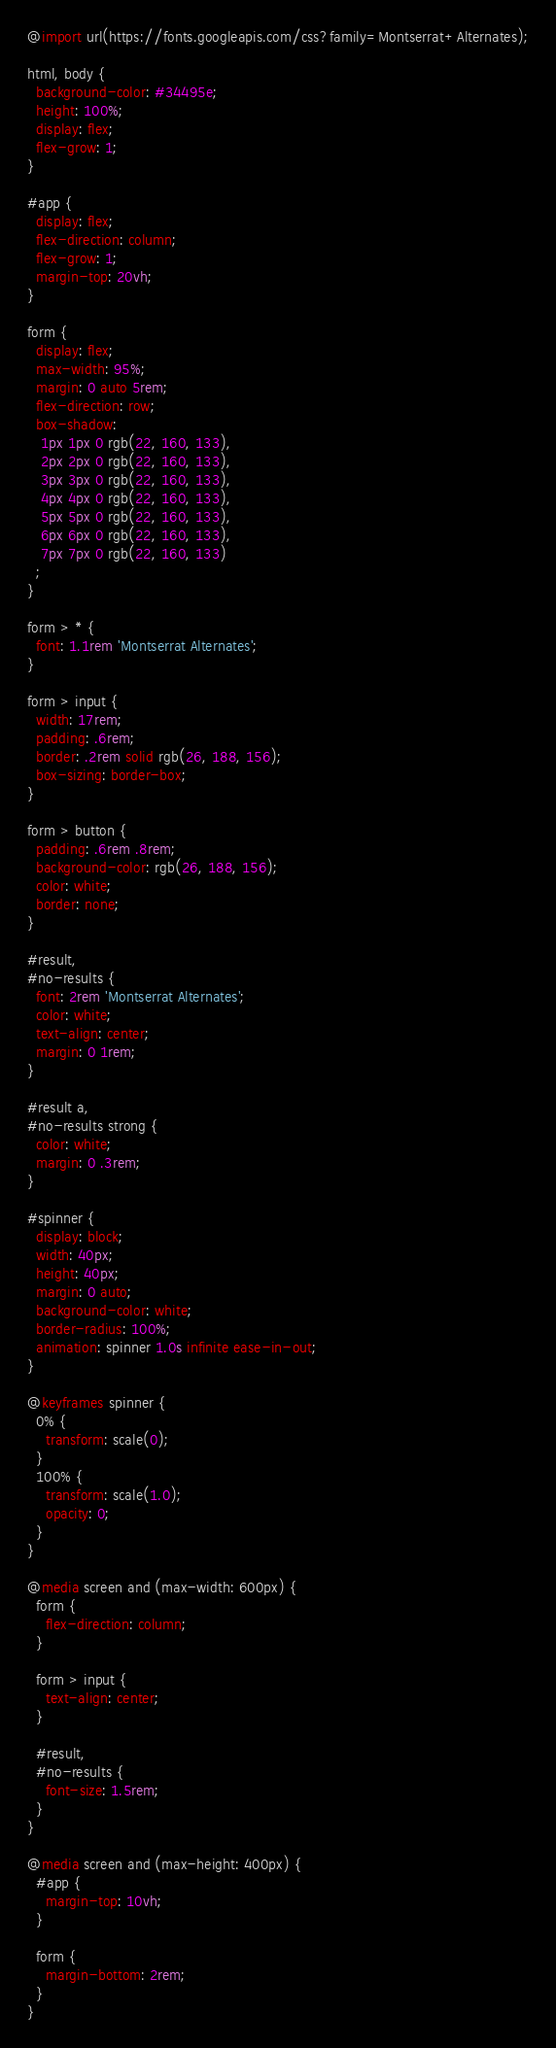<code> <loc_0><loc_0><loc_500><loc_500><_CSS_>@import url(https://fonts.googleapis.com/css?family=Montserrat+Alternates);

html, body {
  background-color: #34495e;
  height: 100%;
  display: flex;
  flex-grow: 1;
}

#app {
  display: flex;
  flex-direction: column;
  flex-grow: 1;
  margin-top: 20vh;
}

form {
  display: flex;
  max-width: 95%;
  margin: 0 auto 5rem;
  flex-direction: row;
  box-shadow:
   1px 1px 0 rgb(22, 160, 133),
   2px 2px 0 rgb(22, 160, 133),
   3px 3px 0 rgb(22, 160, 133),
   4px 4px 0 rgb(22, 160, 133),
   5px 5px 0 rgb(22, 160, 133),
   6px 6px 0 rgb(22, 160, 133),
   7px 7px 0 rgb(22, 160, 133)
  ;
}

form > * {
  font: 1.1rem 'Montserrat Alternates';
}

form > input {
  width: 17rem;
  padding: .6rem;
  border: .2rem solid rgb(26, 188, 156);
  box-sizing: border-box;
}

form > button {
  padding: .6rem .8rem;
  background-color: rgb(26, 188, 156);
  color: white;
  border: none;
}

#result,
#no-results {
  font: 2rem 'Montserrat Alternates';
  color: white;
  text-align: center;
  margin: 0 1rem;
}

#result a,
#no-results strong {
  color: white;
  margin: 0 .3rem;
}

#spinner {
  display: block;
  width: 40px;
  height: 40px;
  margin: 0 auto;
  background-color: white;
  border-radius: 100%;
  animation: spinner 1.0s infinite ease-in-out;
}

@keyframes spinner {
  0% {
    transform: scale(0);
  }
  100% {
    transform: scale(1.0);
    opacity: 0;
  }
}

@media screen and (max-width: 600px) {
  form {
    flex-direction: column;
  }

  form > input {
    text-align: center;
  }

  #result,
  #no-results {
    font-size: 1.5rem;
  }
}

@media screen and (max-height: 400px) {
  #app {
    margin-top: 10vh;
  }

  form {
    margin-bottom: 2rem;
  }
}
</code> 